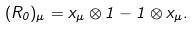Convert formula to latex. <formula><loc_0><loc_0><loc_500><loc_500>( R _ { 0 } ) _ { \mu } = x _ { \mu } \otimes 1 - 1 \otimes x _ { \mu } .</formula> 